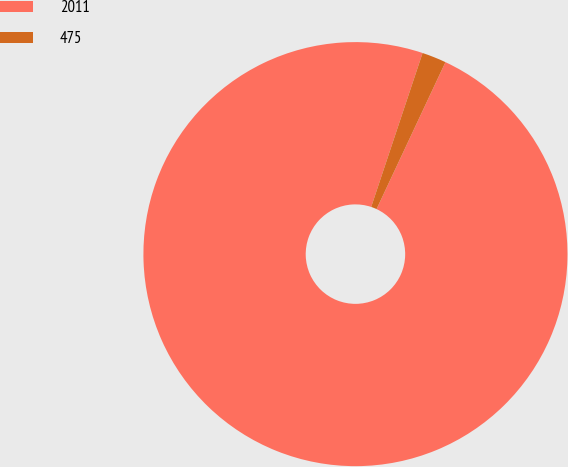Convert chart. <chart><loc_0><loc_0><loc_500><loc_500><pie_chart><fcel>2011<fcel>475<nl><fcel>98.15%<fcel>1.85%<nl></chart> 